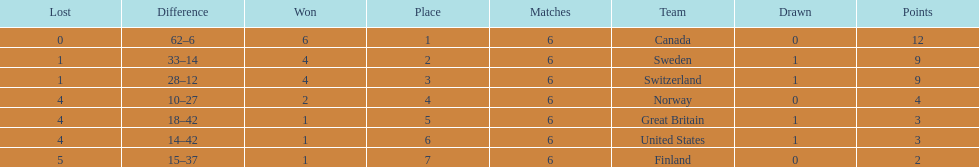Which country conceded the least goals? Finland. 